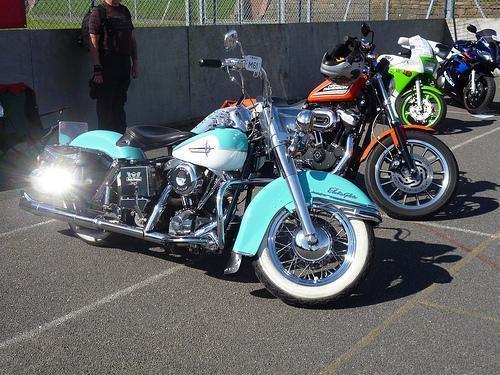How many motorcycles?
Give a very brief answer. 4. 